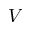<formula> <loc_0><loc_0><loc_500><loc_500>V</formula> 